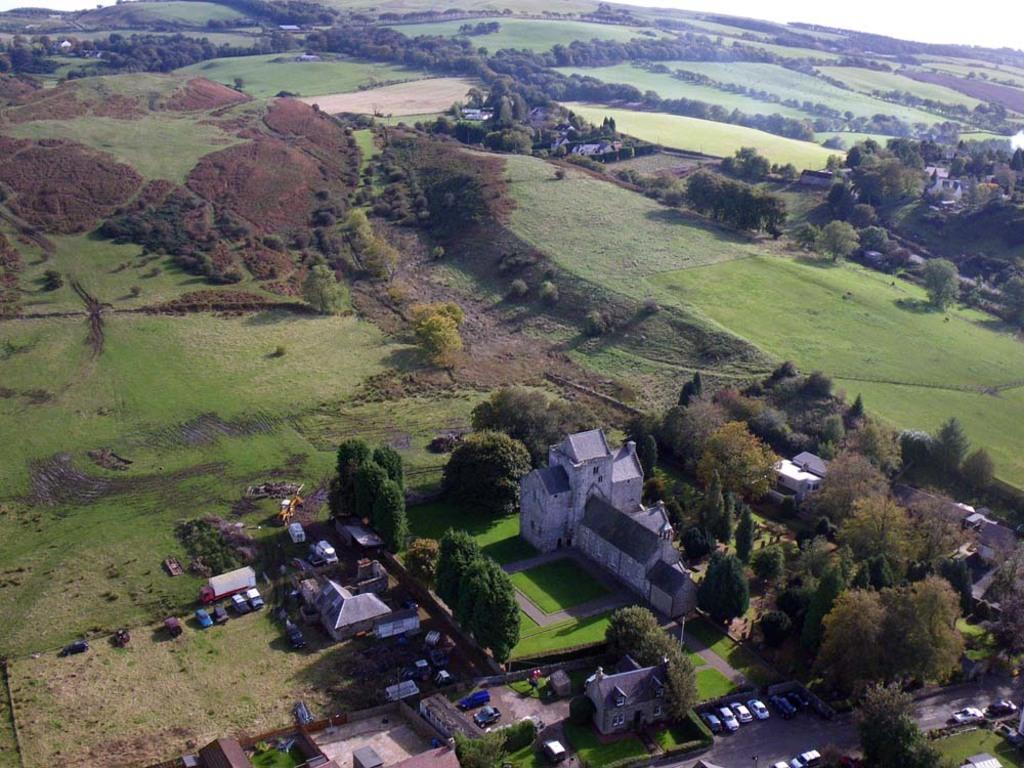In one or two sentences, can you explain what this image depicts? In this image we can see houses, trees, grass, vehicles. 